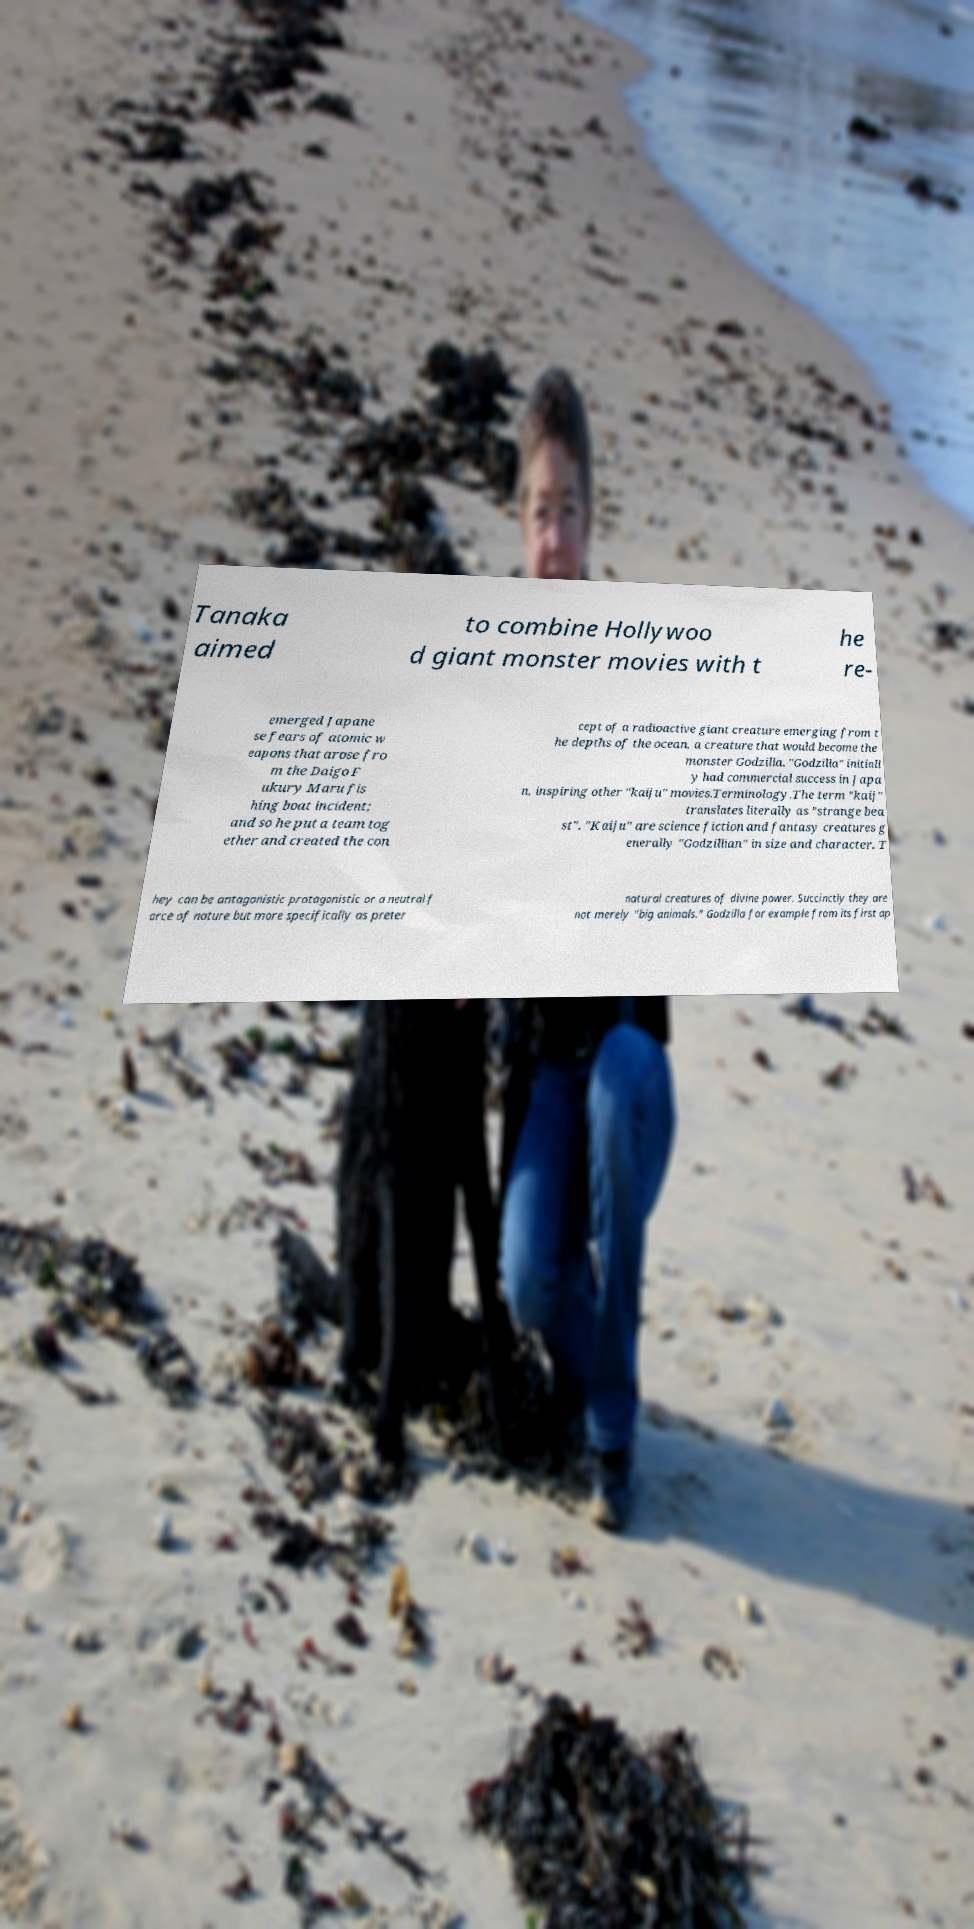Can you accurately transcribe the text from the provided image for me? Tanaka aimed to combine Hollywoo d giant monster movies with t he re- emerged Japane se fears of atomic w eapons that arose fro m the Daigo F ukury Maru fis hing boat incident; and so he put a team tog ether and created the con cept of a radioactive giant creature emerging from t he depths of the ocean, a creature that would become the monster Godzilla. "Godzilla" initiall y had commercial success in Japa n, inspiring other "kaiju" movies.Terminology.The term "kaij" translates literally as "strange bea st". "Kaiju" are science fiction and fantasy creatures g enerally "Godzillian" in size and character. T hey can be antagonistic protagonistic or a neutral f orce of nature but more specifically as preter natural creatures of divine power. Succinctly they are not merely "big animals." Godzilla for example from its first ap 